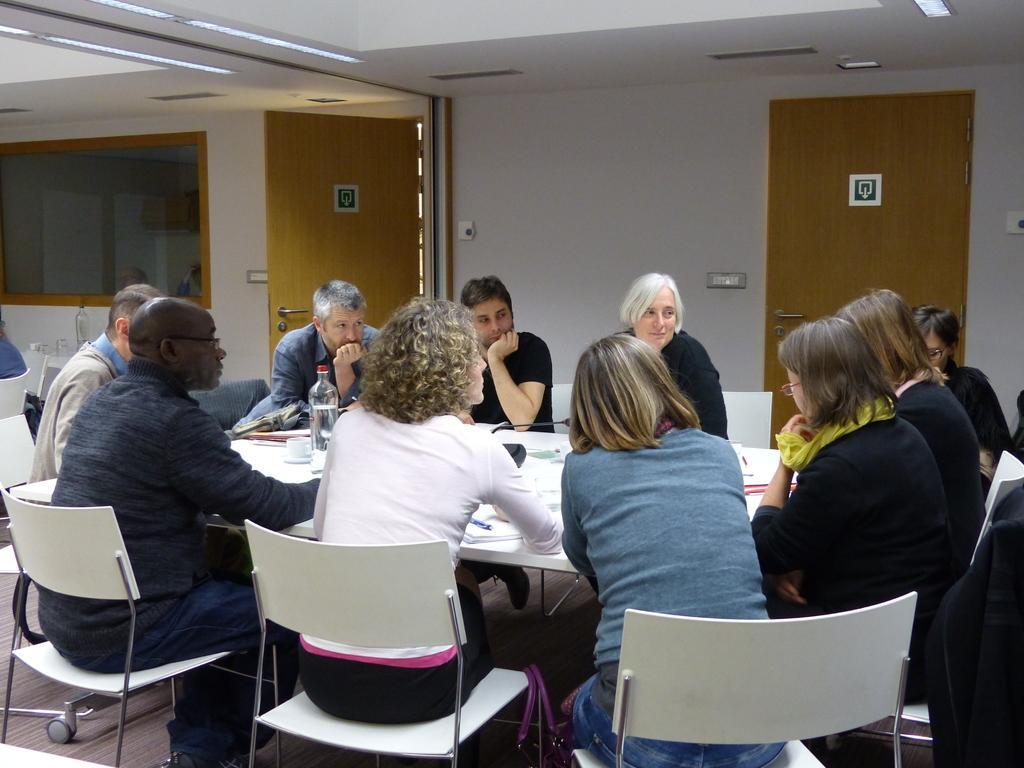Can you describe this image briefly? This Image is clicked in a room. There are lights on the top, there is a table and chairs around the table. People are sitting in chairs. There is a door on the right side. On the table there is a bottle, cap, paper. 